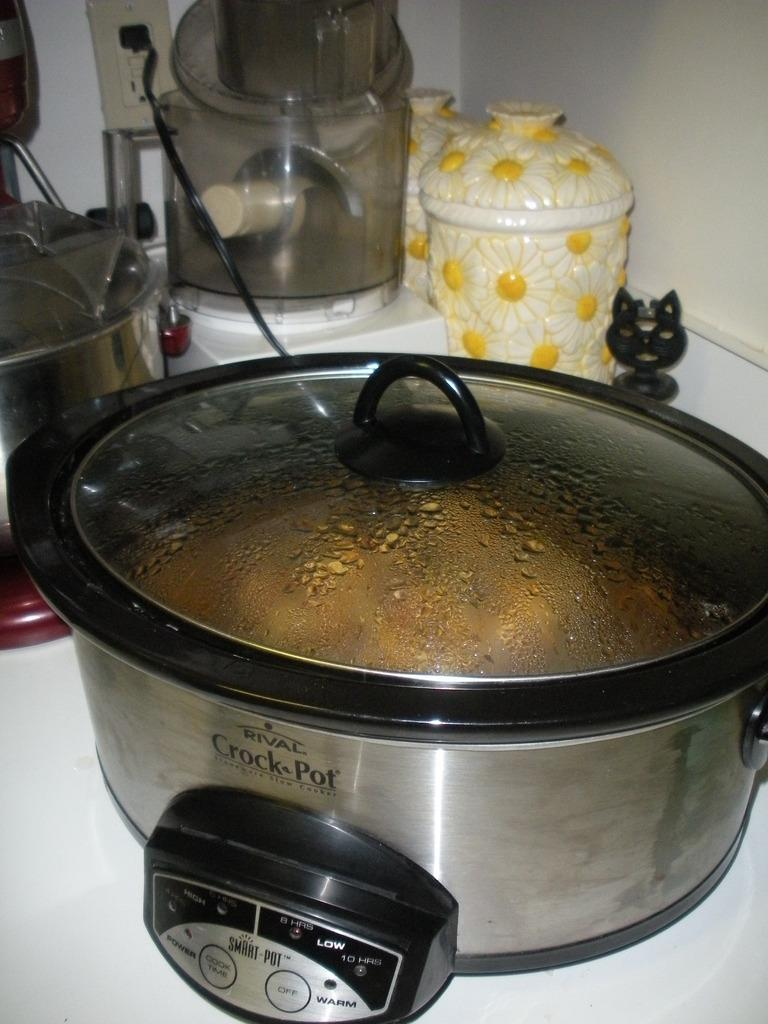<image>
Summarize the visual content of the image. the crock pot slow cooker with some food with wire connection is placed in front of designer ceramic pot 